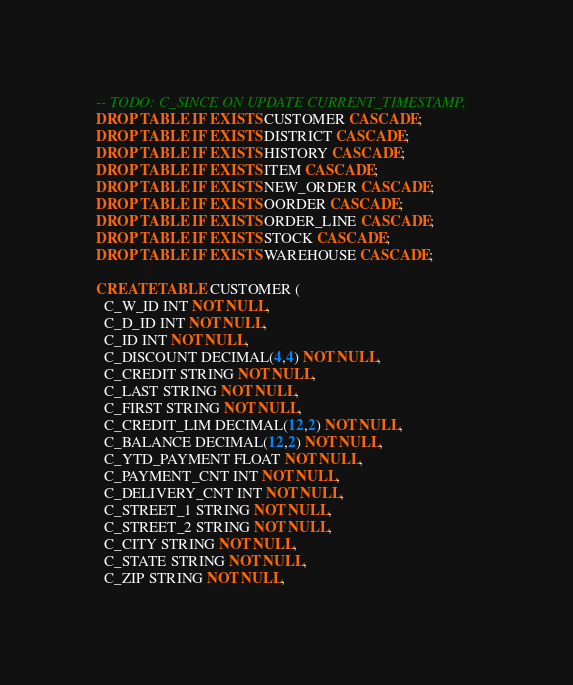<code> <loc_0><loc_0><loc_500><loc_500><_SQL_>-- TODO: C_SINCE ON UPDATE CURRENT_TIMESTAMP,
DROP TABLE IF EXISTS CUSTOMER CASCADE;
DROP TABLE IF EXISTS DISTRICT CASCADE;
DROP TABLE IF EXISTS HISTORY CASCADE;
DROP TABLE IF EXISTS ITEM CASCADE;
DROP TABLE IF EXISTS NEW_ORDER CASCADE;
DROP TABLE IF EXISTS OORDER CASCADE;
DROP TABLE IF EXISTS ORDER_LINE CASCADE;
DROP TABLE IF EXISTS STOCK CASCADE;
DROP TABLE IF EXISTS WAREHOUSE CASCADE;

CREATE TABLE CUSTOMER (
  C_W_ID INT NOT NULL,
  C_D_ID INT NOT NULL,
  C_ID INT NOT NULL,
  C_DISCOUNT DECIMAL(4,4) NOT NULL,
  C_CREDIT STRING NOT NULL,
  C_LAST STRING NOT NULL,
  C_FIRST STRING NOT NULL,
  C_CREDIT_LIM DECIMAL(12,2) NOT NULL,
  C_BALANCE DECIMAL(12,2) NOT NULL,
  C_YTD_PAYMENT FLOAT NOT NULL,
  C_PAYMENT_CNT INT NOT NULL,
  C_DELIVERY_CNT INT NOT NULL,
  C_STREET_1 STRING NOT NULL,
  C_STREET_2 STRING NOT NULL,
  C_CITY STRING NOT NULL,
  C_STATE STRING NOT NULL,
  C_ZIP STRING NOT NULL,</code> 